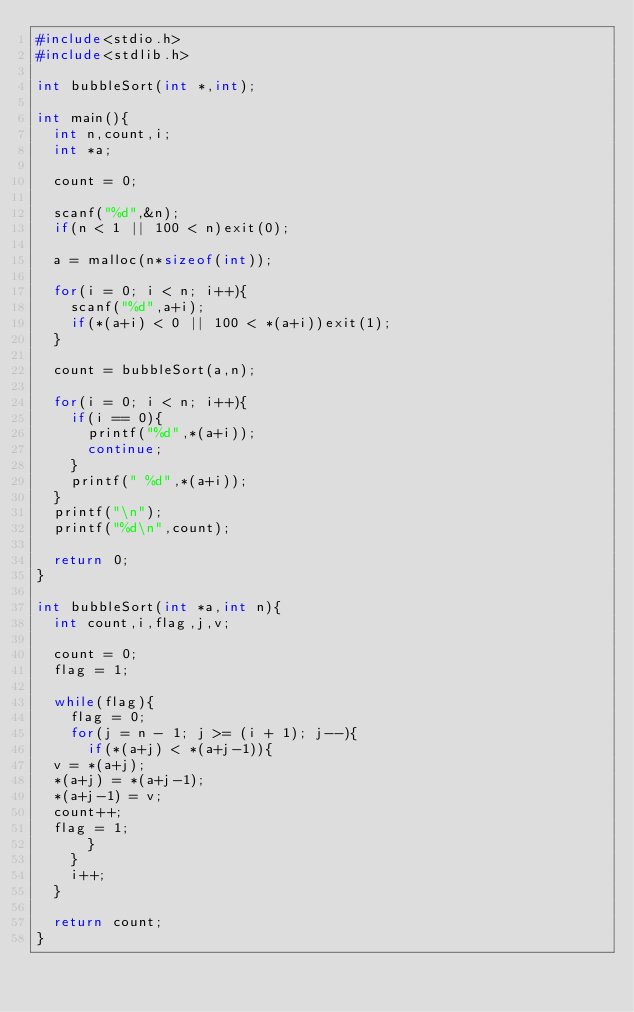Convert code to text. <code><loc_0><loc_0><loc_500><loc_500><_C_>#include<stdio.h>
#include<stdlib.h>

int bubbleSort(int *,int);

int main(){
  int n,count,i;
  int *a;

  count = 0;
  
  scanf("%d",&n);
  if(n < 1 || 100 < n)exit(0);

  a = malloc(n*sizeof(int));

  for(i = 0; i < n; i++){
    scanf("%d",a+i);
    if(*(a+i) < 0 || 100 < *(a+i))exit(1);
  }
  
  count = bubbleSort(a,n);
  
  for(i = 0; i < n; i++){
    if(i == 0){
      printf("%d",*(a+i));
      continue;
    }
    printf(" %d",*(a+i));
  }
  printf("\n");
  printf("%d\n",count);
  
  return 0;
}

int bubbleSort(int *a,int n){
  int count,i,flag,j,v;

  count = 0;
  flag = 1;
  
  while(flag){
    flag = 0;
    for(j = n - 1; j >= (i + 1); j--){
      if(*(a+j) < *(a+j-1)){
	v = *(a+j);
	*(a+j) = *(a+j-1);
	*(a+j-1) = v;
	count++;
	flag = 1;
      } 
    }
    i++;
  }
  
  return count;
}

</code> 